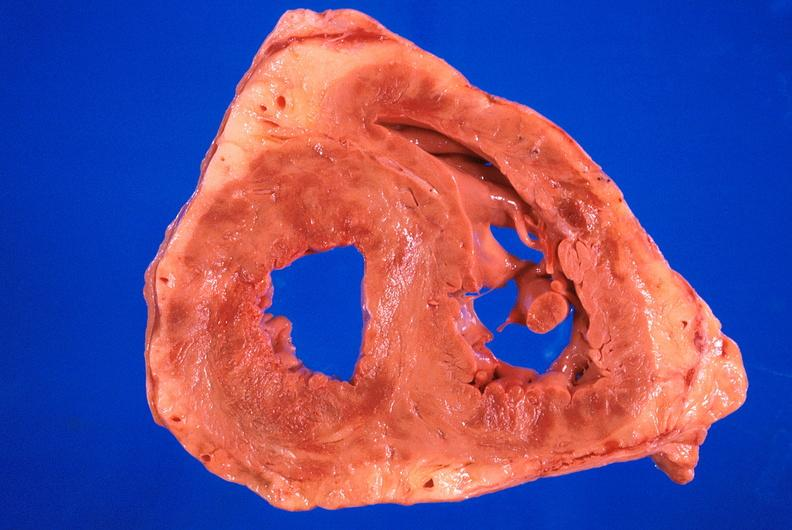what is present?
Answer the question using a single word or phrase. Cardiovascular 